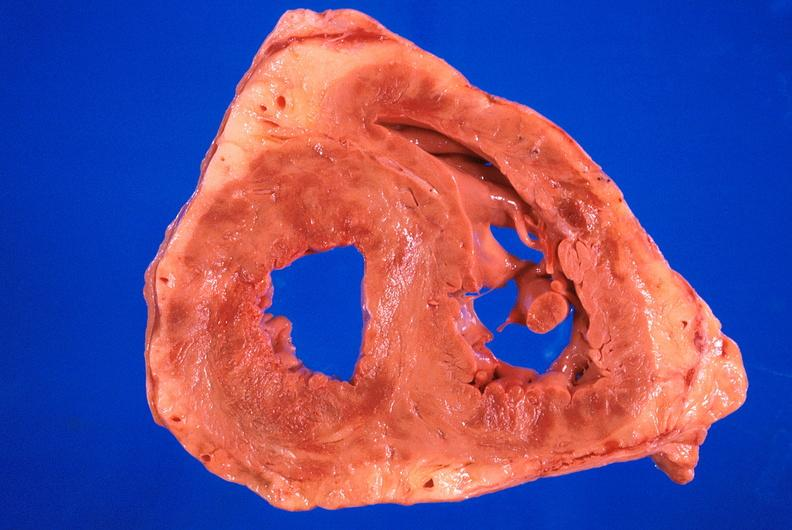what is present?
Answer the question using a single word or phrase. Cardiovascular 